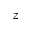<formula> <loc_0><loc_0><loc_500><loc_500>z</formula> 